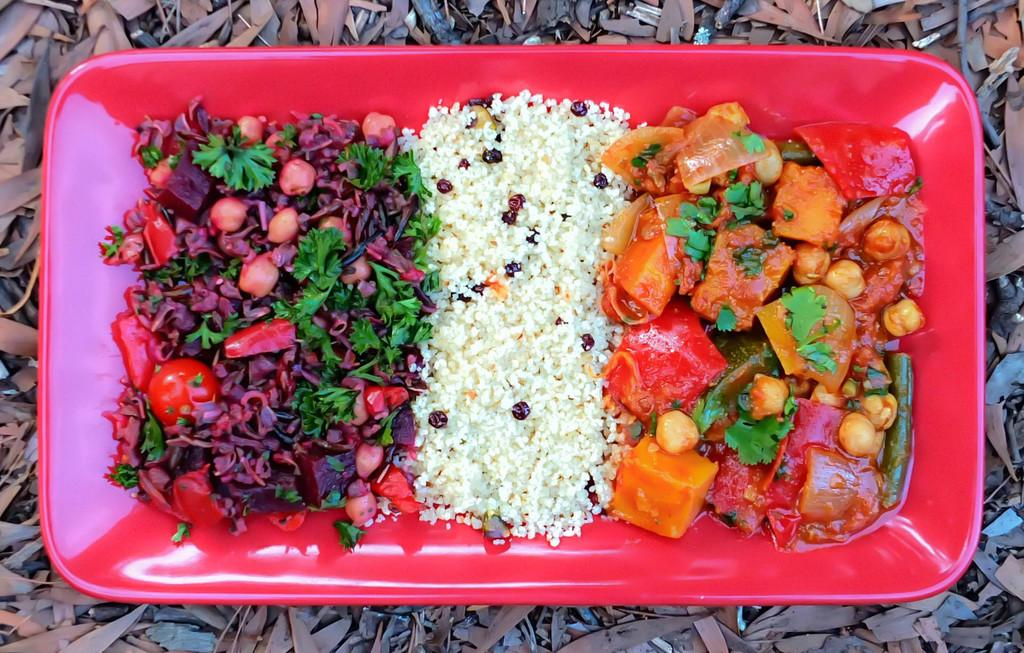What is present on the plate in the image? The food is on a plate in the image. Can you describe the color of the plate? The plate is red. What can be seen on the ground in the image? There are dry leaves and small stems on the ground in the image. What type of creature is shown in the middle of the plate in the image? There is no creature present on the plate in the image; it contains food. What kind of powder is sprinkled over the food in the image? There is no powder visible on the food in the image. 